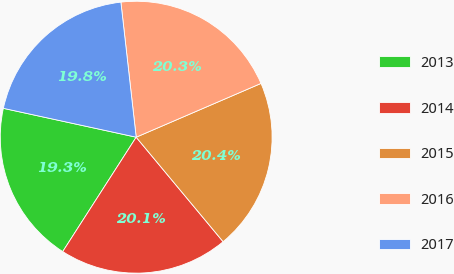<chart> <loc_0><loc_0><loc_500><loc_500><pie_chart><fcel>2013<fcel>2014<fcel>2015<fcel>2016<fcel>2017<nl><fcel>19.32%<fcel>20.13%<fcel>20.43%<fcel>20.32%<fcel>19.8%<nl></chart> 